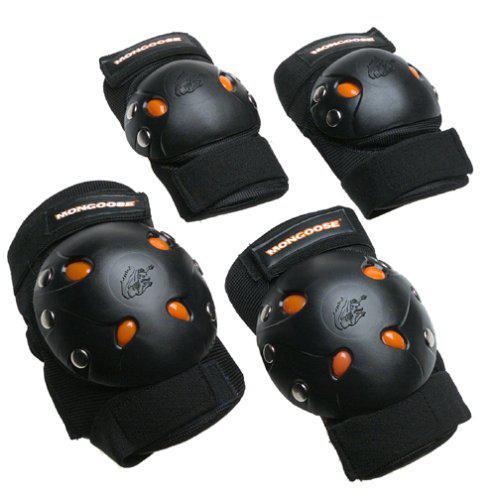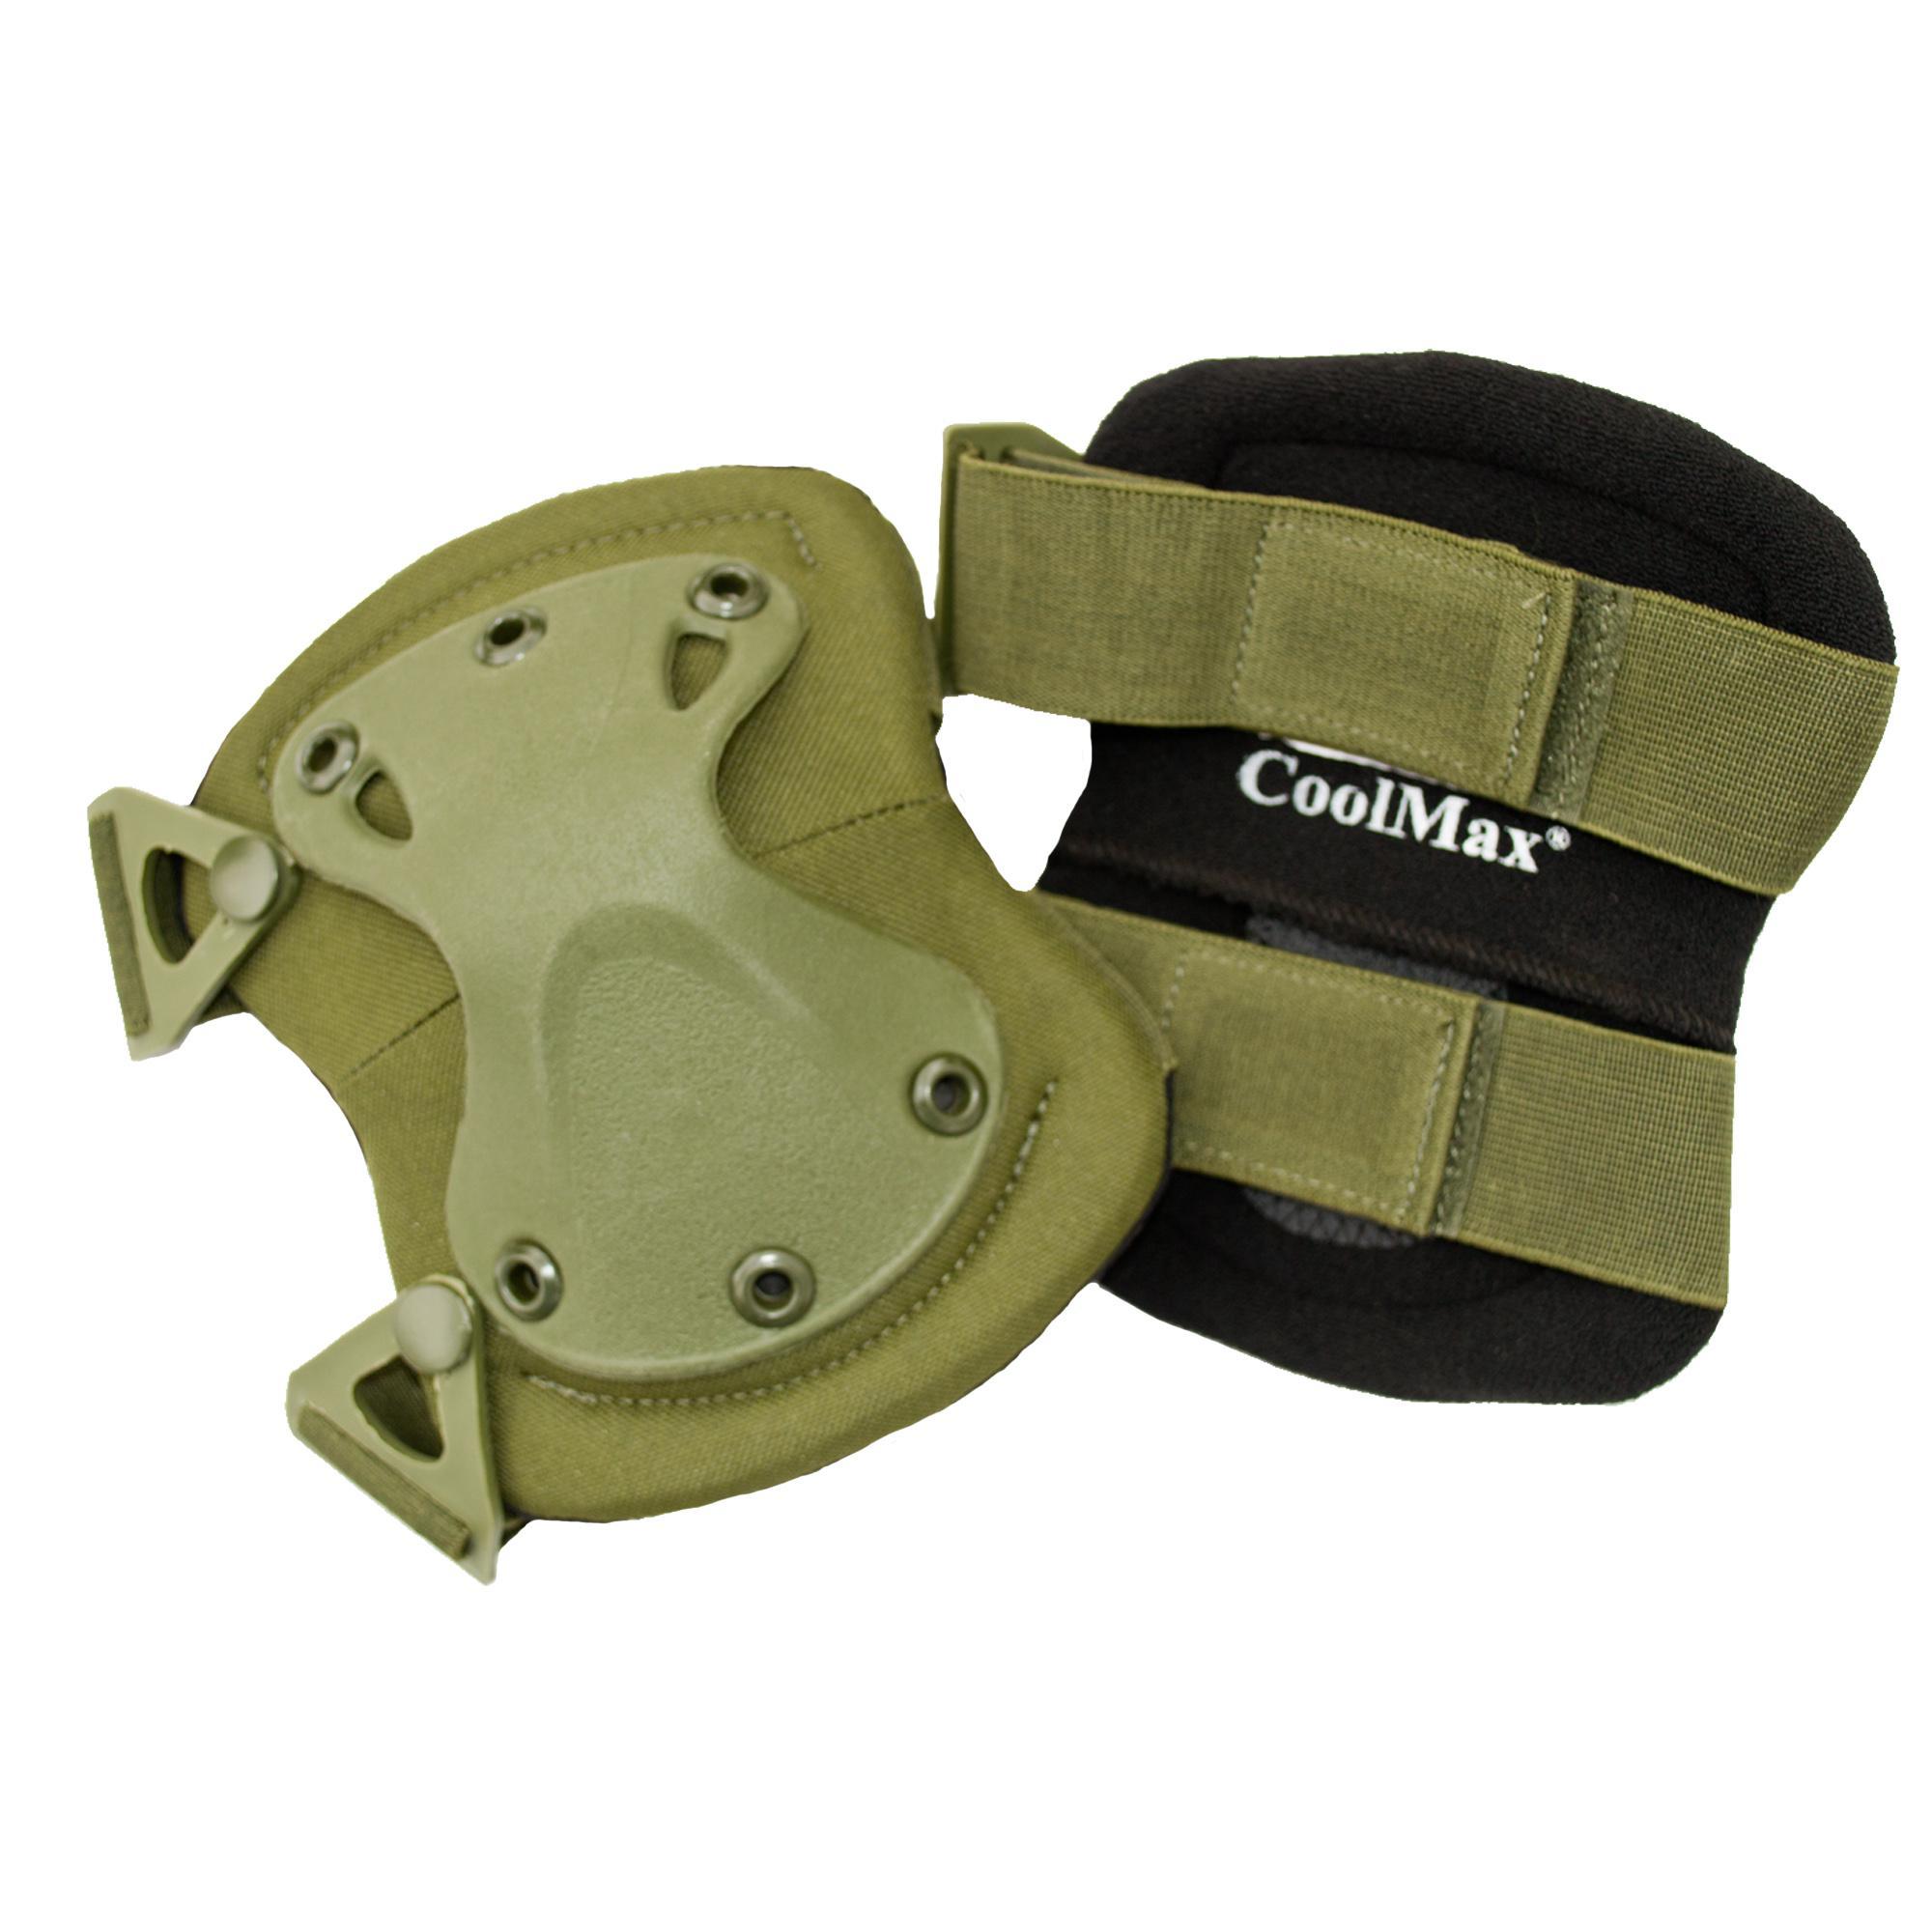The first image is the image on the left, the second image is the image on the right. For the images shown, is this caption "The image on the left has kneepads with only neutral colors such as black and white on it." true? Answer yes or no. No. The first image is the image on the left, the second image is the image on the right. Analyze the images presented: Is the assertion "An image includes fingerless gloves and two pairs of pads." valid? Answer yes or no. No. 